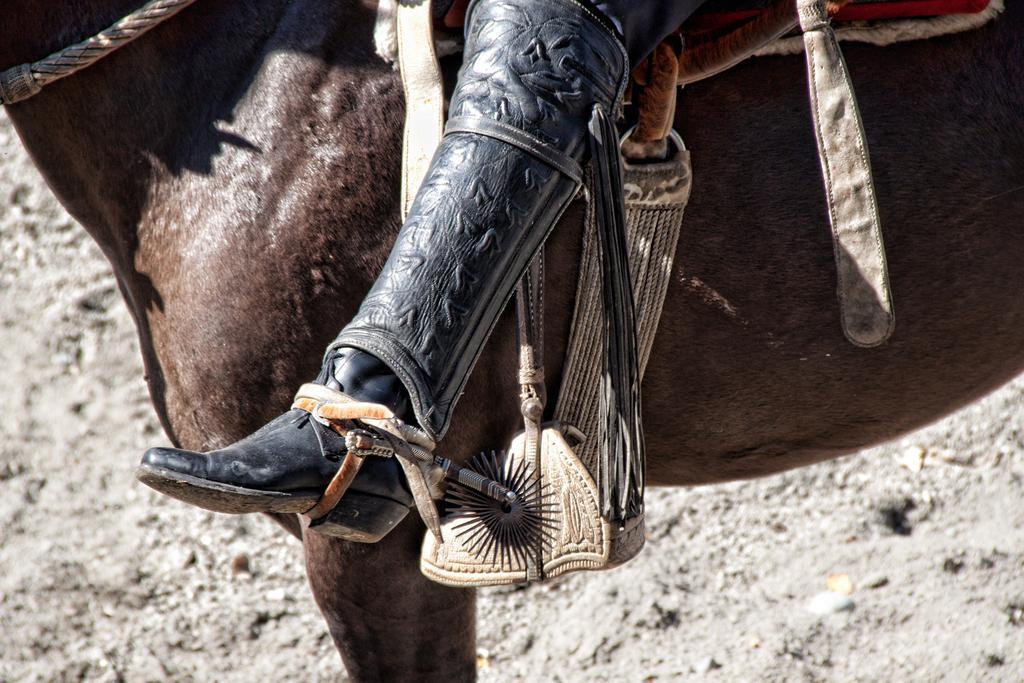Describe this image in one or two sentences. In this image in the center there is one horse, on the horse there is one person who is sitting. At the bottom there is sand. 